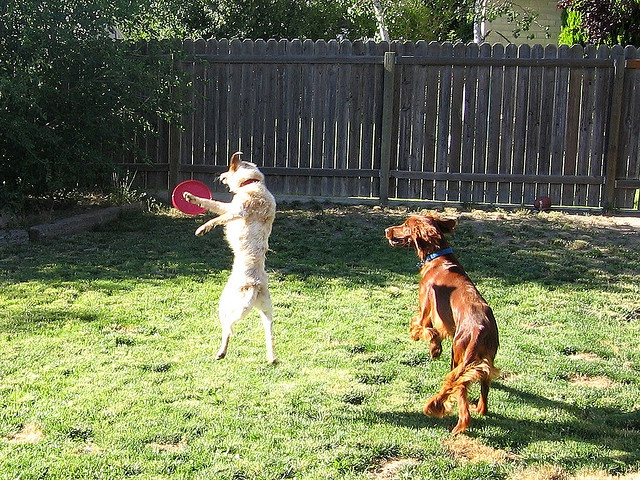Describe the objects in this image and their specific colors. I can see dog in black, tan, maroon, and khaki tones, dog in black, white, darkgray, khaki, and tan tones, and frisbee in black, brown, and maroon tones in this image. 